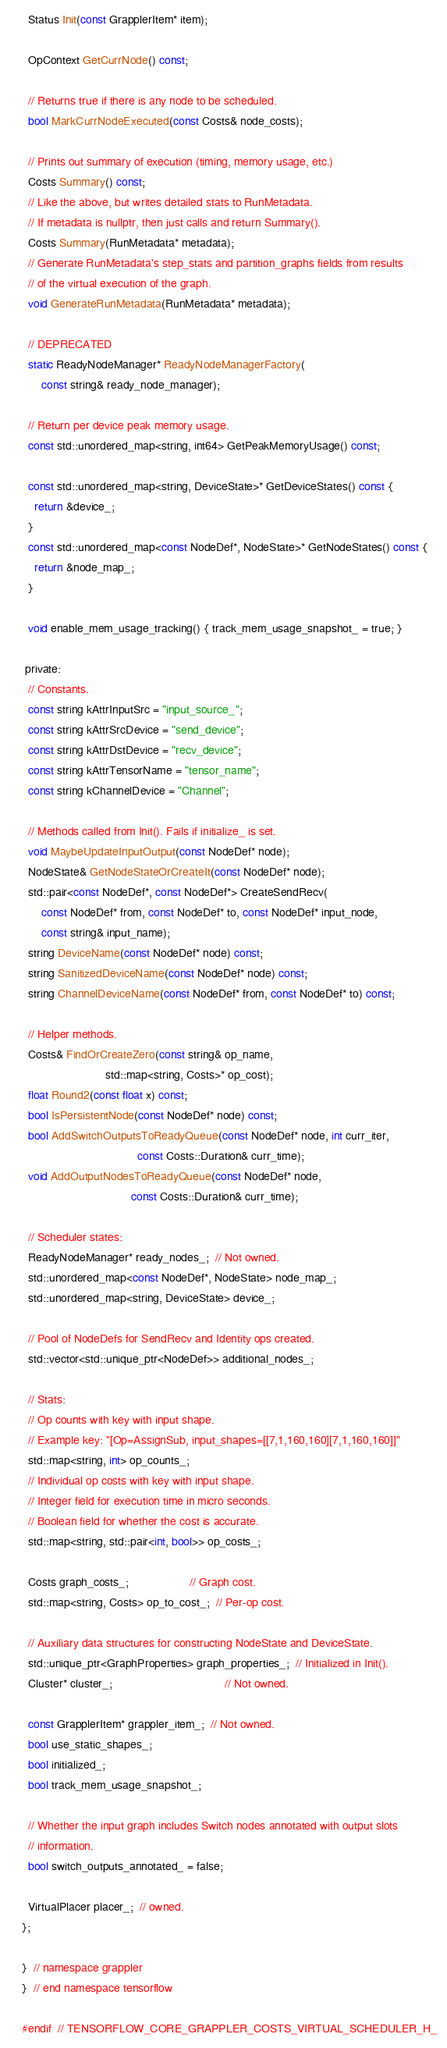Convert code to text. <code><loc_0><loc_0><loc_500><loc_500><_C_>  Status Init(const GrapplerItem* item);

  OpContext GetCurrNode() const;

  // Returns true if there is any node to be scheduled.
  bool MarkCurrNodeExecuted(const Costs& node_costs);

  // Prints out summary of execution (timing, memory usage, etc.)
  Costs Summary() const;
  // Like the above, but writes detailed stats to RunMetadata.
  // If metadata is nullptr, then just calls and return Summary().
  Costs Summary(RunMetadata* metadata);
  // Generate RunMetadata's step_stats and partition_graphs fields from results
  // of the virtual execution of the graph.
  void GenerateRunMetadata(RunMetadata* metadata);

  // DEPRECATED
  static ReadyNodeManager* ReadyNodeManagerFactory(
      const string& ready_node_manager);

  // Return per device peak memory usage.
  const std::unordered_map<string, int64> GetPeakMemoryUsage() const;

  const std::unordered_map<string, DeviceState>* GetDeviceStates() const {
    return &device_;
  }
  const std::unordered_map<const NodeDef*, NodeState>* GetNodeStates() const {
    return &node_map_;
  }

  void enable_mem_usage_tracking() { track_mem_usage_snapshot_ = true; }

 private:
  // Constants.
  const string kAttrInputSrc = "input_source_";
  const string kAttrSrcDevice = "send_device";
  const string kAttrDstDevice = "recv_device";
  const string kAttrTensorName = "tensor_name";
  const string kChannelDevice = "Channel";

  // Methods called from Init(). Fails if initialize_ is set.
  void MaybeUpdateInputOutput(const NodeDef* node);
  NodeState& GetNodeStateOrCreateIt(const NodeDef* node);
  std::pair<const NodeDef*, const NodeDef*> CreateSendRecv(
      const NodeDef* from, const NodeDef* to, const NodeDef* input_node,
      const string& input_name);
  string DeviceName(const NodeDef* node) const;
  string SanitizedDeviceName(const NodeDef* node) const;
  string ChannelDeviceName(const NodeDef* from, const NodeDef* to) const;

  // Helper methods.
  Costs& FindOrCreateZero(const string& op_name,
                          std::map<string, Costs>* op_cost);
  float Round2(const float x) const;
  bool IsPersistentNode(const NodeDef* node) const;
  bool AddSwitchOutputsToReadyQueue(const NodeDef* node, int curr_iter,
                                    const Costs::Duration& curr_time);
  void AddOutputNodesToReadyQueue(const NodeDef* node,
                                  const Costs::Duration& curr_time);

  // Scheduler states:
  ReadyNodeManager* ready_nodes_;  // Not owned.
  std::unordered_map<const NodeDef*, NodeState> node_map_;
  std::unordered_map<string, DeviceState> device_;

  // Pool of NodeDefs for SendRecv and Identity ops created.
  std::vector<std::unique_ptr<NodeDef>> additional_nodes_;

  // Stats:
  // Op counts with key with input shape.
  // Example key: "[Op=AssignSub, input_shapes=[[7,1,160,160][7,1,160,160]]"
  std::map<string, int> op_counts_;
  // Individual op costs with key with input shape.
  // Integer field for execution time in micro seconds.
  // Boolean field for whether the cost is accurate.
  std::map<string, std::pair<int, bool>> op_costs_;

  Costs graph_costs_;                   // Graph cost.
  std::map<string, Costs> op_to_cost_;  // Per-op cost.

  // Auxiliary data structures for constructing NodeState and DeviceState.
  std::unique_ptr<GraphProperties> graph_properties_;  // Initialized in Init().
  Cluster* cluster_;                                   // Not owned.

  const GrapplerItem* grappler_item_;  // Not owned.
  bool use_static_shapes_;
  bool initialized_;
  bool track_mem_usage_snapshot_;

  // Whether the input graph includes Switch nodes annotated with output slots
  // information.
  bool switch_outputs_annotated_ = false;

  VirtualPlacer placer_;  // owned.
};

}  // namespace grappler
}  // end namespace tensorflow

#endif  // TENSORFLOW_CORE_GRAPPLER_COSTS_VIRTUAL_SCHEDULER_H_
</code> 